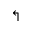<formula> <loc_0><loc_0><loc_500><loc_500>\L s h</formula> 